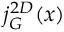Convert formula to latex. <formula><loc_0><loc_0><loc_500><loc_500>j _ { G } ^ { 2 D } ( x )</formula> 